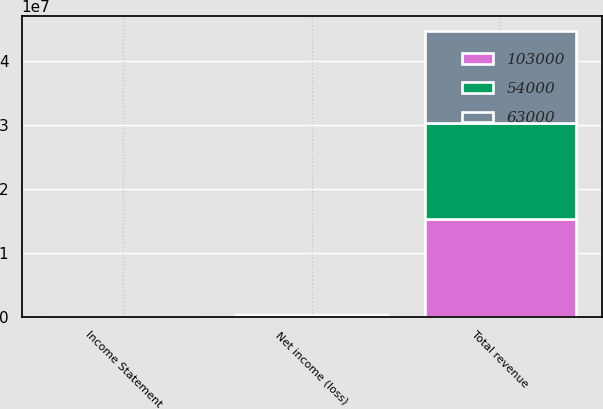Convert chart. <chart><loc_0><loc_0><loc_500><loc_500><stacked_bar_chart><ecel><fcel>Income Statement<fcel>Total revenue<fcel>Net income (loss)<nl><fcel>54000<fcel>2010<fcel>1.5074e+07<fcel>63000<nl><fcel>63000<fcel>2009<fcel>1.4397e+07<fcel>103000<nl><fcel>103000<fcel>2008<fcel>1.5313e+07<fcel>54000<nl></chart> 